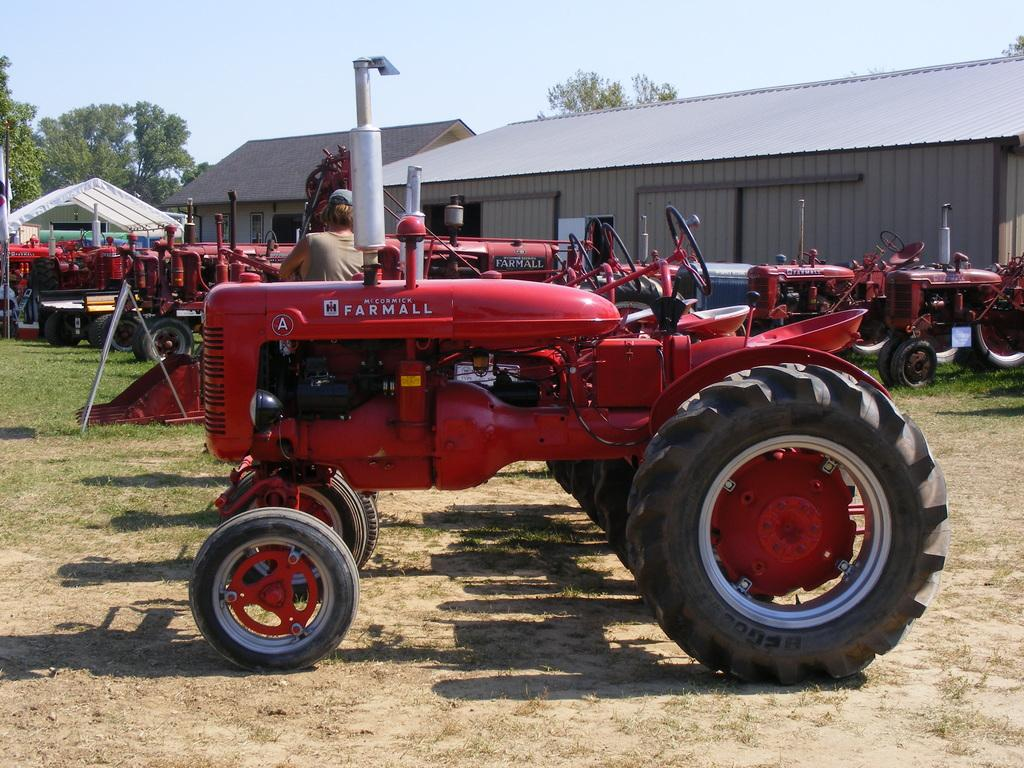What types of objects are present in the image? There are vehicles and a person standing in the image. Can you describe the setting in the background? There are sheds and green trees in the background of the image. What can be seen in the sky in the image? The sky is visible in the image, with a combination of white and blue colors. colors. What type of bait is being used by the person in the image? There is no indication of fishing or bait in the image; it features vehicles, a person, sheds, green trees, and a sky with a combination of white and blue colors. Can you tell me how many toothbrushes are visible in the image? There are no toothbrushes present in the image. 